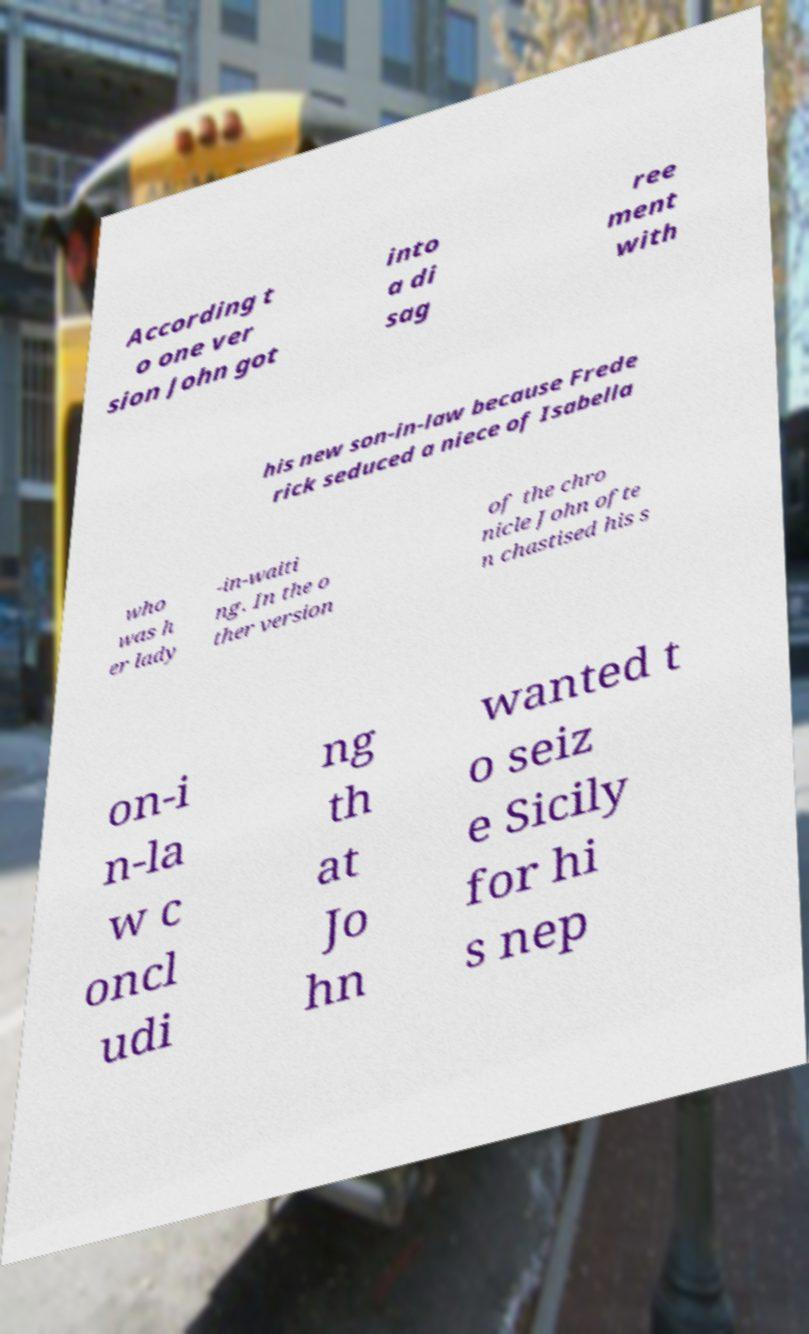There's text embedded in this image that I need extracted. Can you transcribe it verbatim? According t o one ver sion John got into a di sag ree ment with his new son-in-law because Frede rick seduced a niece of Isabella who was h er lady -in-waiti ng. In the o ther version of the chro nicle John ofte n chastised his s on-i n-la w c oncl udi ng th at Jo hn wanted t o seiz e Sicily for hi s nep 